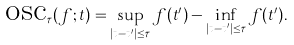Convert formula to latex. <formula><loc_0><loc_0><loc_500><loc_500>\text {osc} _ { \tau } ( f ; t ) = \sup _ { | t - t ^ { \prime } | \leq \tau } f ( t ^ { \prime } ) - \inf _ { | t - t ^ { \prime } | \leq \tau } f ( t ^ { \prime } ) .</formula> 